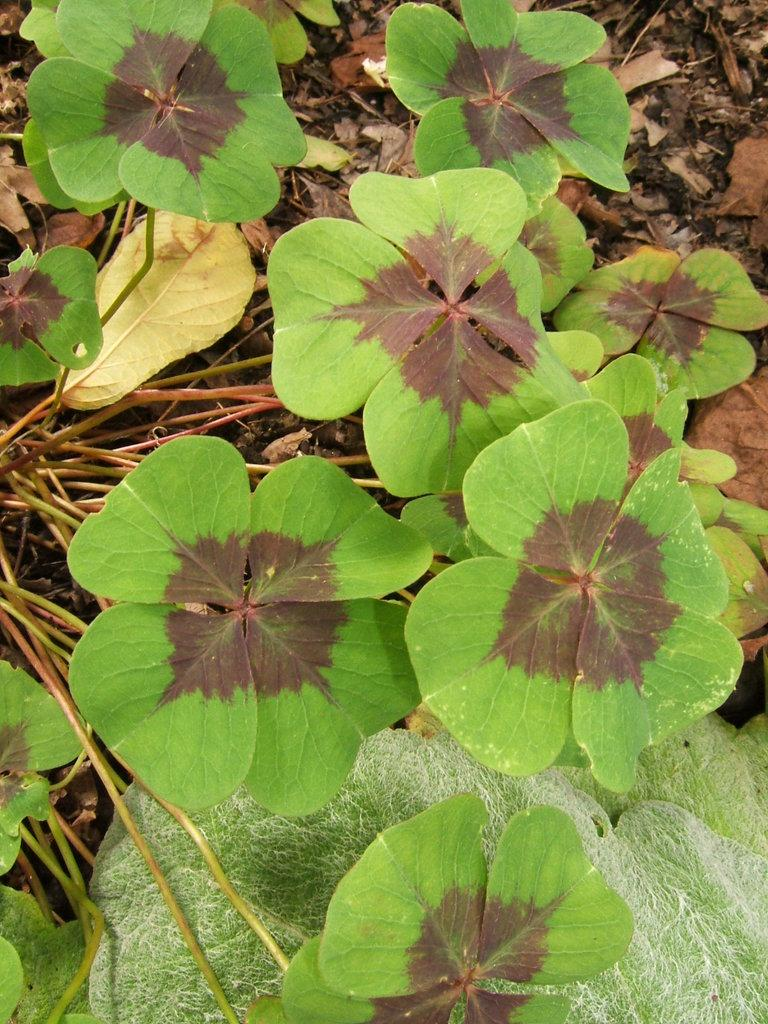What type of living organisms can be seen in the image? Plants can be seen in the image. What colors are present on the plants in the image? The plants have green and brown colors. What can be found on the ground in the image? There are leaves on the ground in the image. What is the price of the team in the image? There is no team present in the image, and therefore no price can be determined. 